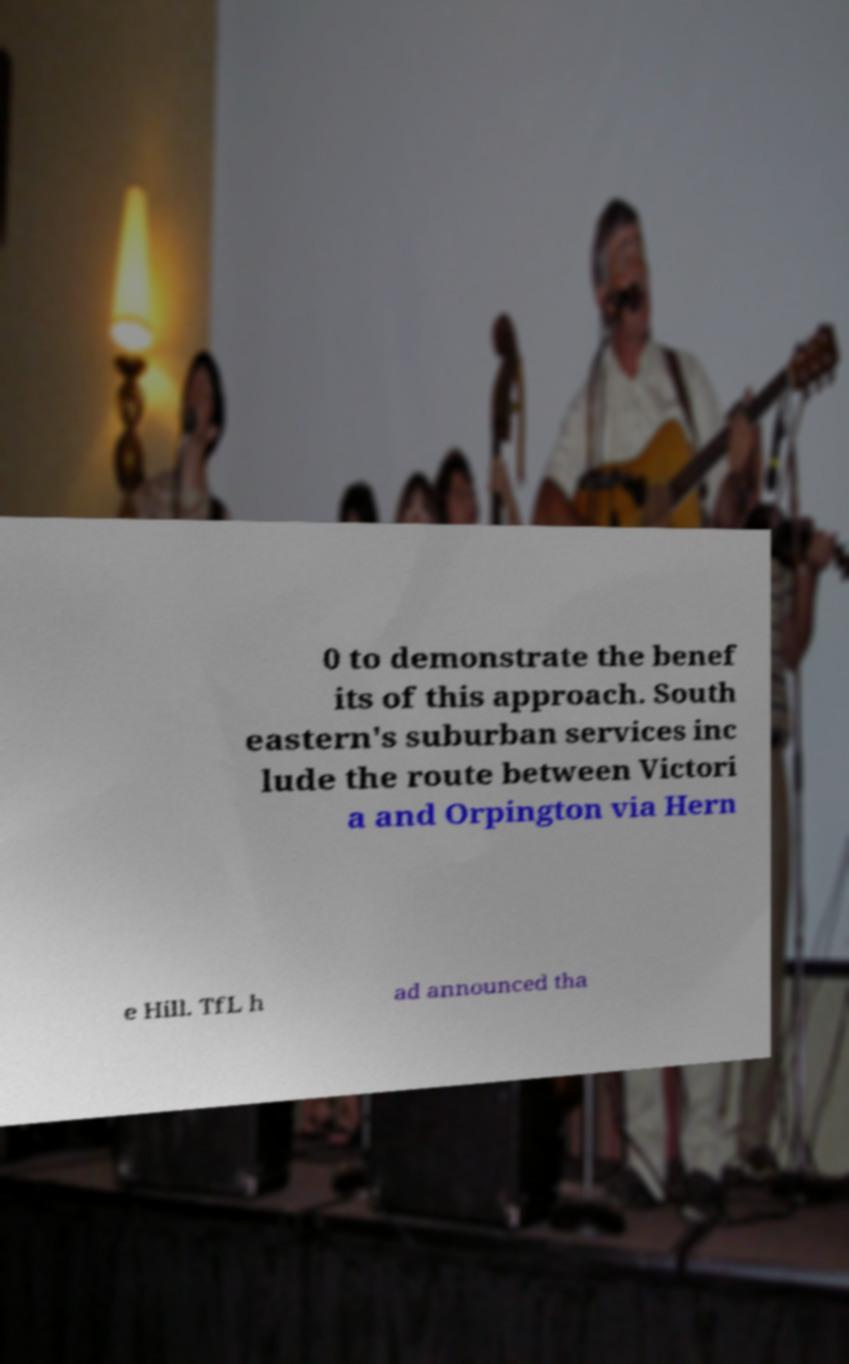I need the written content from this picture converted into text. Can you do that? 0 to demonstrate the benef its of this approach. South eastern's suburban services inc lude the route between Victori a and Orpington via Hern e Hill. TfL h ad announced tha 